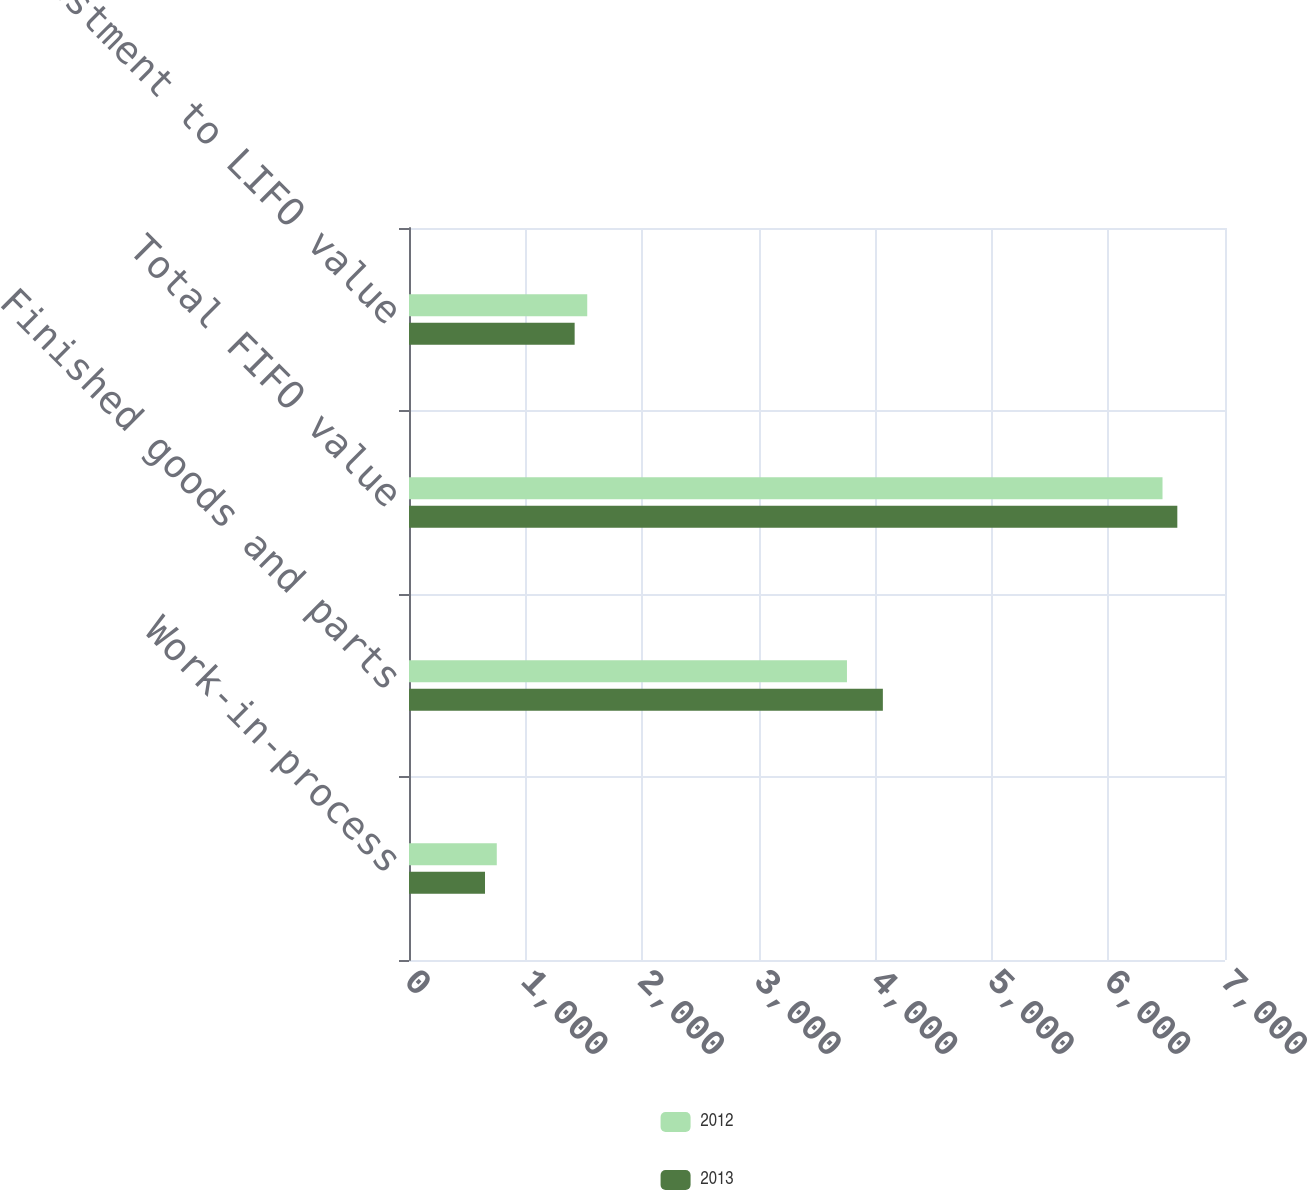<chart> <loc_0><loc_0><loc_500><loc_500><stacked_bar_chart><ecel><fcel>Work-in-process<fcel>Finished goods and parts<fcel>Total FIFO value<fcel>Less adjustment to LIFO value<nl><fcel>2012<fcel>753<fcel>3757<fcel>6464<fcel>1529<nl><fcel>2013<fcel>652<fcel>4065<fcel>6591<fcel>1421<nl></chart> 